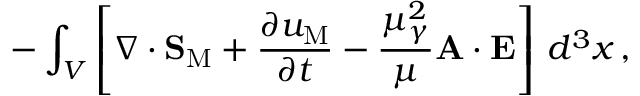Convert formula to latex. <formula><loc_0><loc_0><loc_500><loc_500>- \int _ { V } \left [ \nabla \cdot { S } _ { M } + \frac { \partial u _ { M } } { \partial t } - \frac { \mu _ { \gamma } ^ { 2 } } { \mu } { A } \cdot { E } \right ] \, d ^ { 3 } x \, ,</formula> 